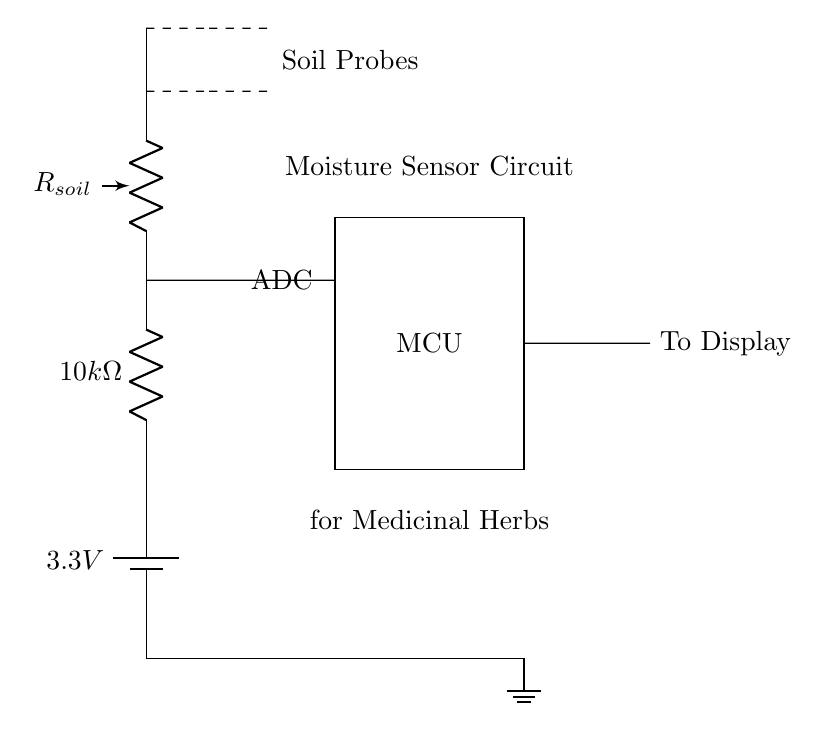What is the voltage of this circuit? The circuit operates at a voltage of 3.3 volts, indicated by the battery symbol in the circuit diagram.
Answer: 3.3 volts What type of resistor is used in the moisture sensor circuit? The circuit includes a 10k ohm resistor, clearly labeled next to the resistor symbol.
Answer: 10k ohm How many soil probes are connected to the circuit? The circuit shows two dashed lines leading to the soil probes, indicating that there are two probes connected for measuring soil moisture.
Answer: Two What is the function of the microcontroller in this circuit? The microcontroller, represented as a rectangle labeled "MCU," processes the analog signal from the moisture sensor and controls the output to a display based on the moisture level detected.
Answer: Processing Why is a voltage divider used in this circuit? A voltage divider is used to scale the voltage from the soil resistance (obtained by the soil probes) to an appropriate level that can be read by the microcontroller (via the ADC). This allows for accurate moisture level readings.
Answer: Scaling voltage What is the purpose of the ADC component in this circuit? The ADC (Analog-to-Digital Converter) converts the analog voltage from the moisture sensor into a digital signal that the microcontroller can read and process for display.
Answer: Conversion What is indicated by the dashed lines in the diagram? The dashed lines represent connections to the soil probes, indicating the connection points for measuring moisture levels in the soil of the medicinal herbs.
Answer: Soil probes connections 